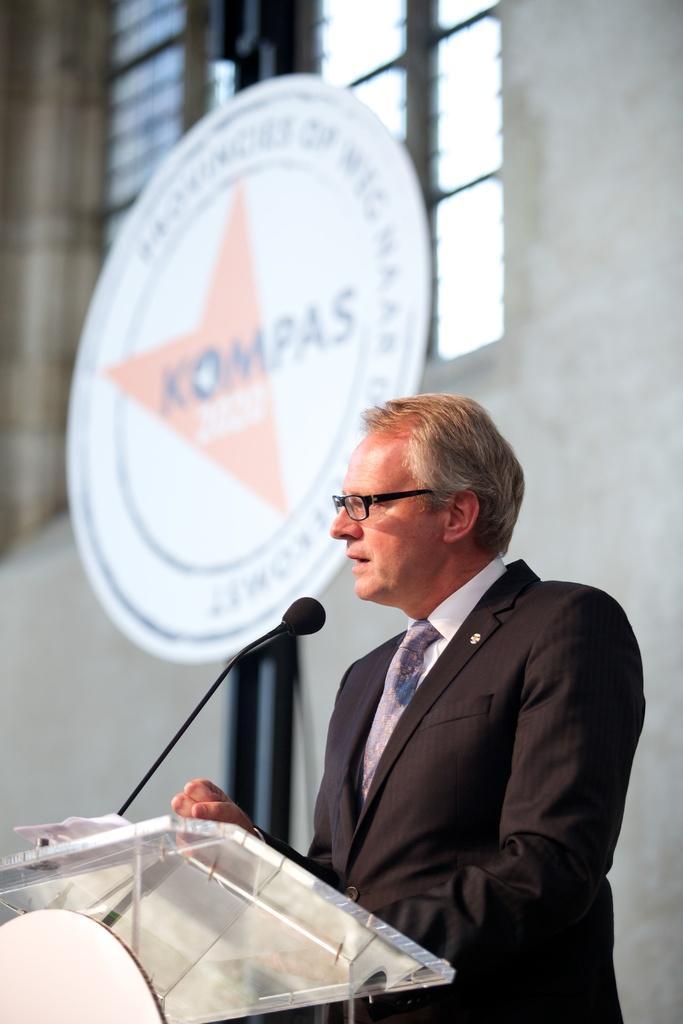How would you summarize this image in a sentence or two? In this image on the right, there is a man, he wears a suit, shirt, tie, in front of him there is a podium, mic, papers. In the background there is a board, text, logo, window, glass and wall. 